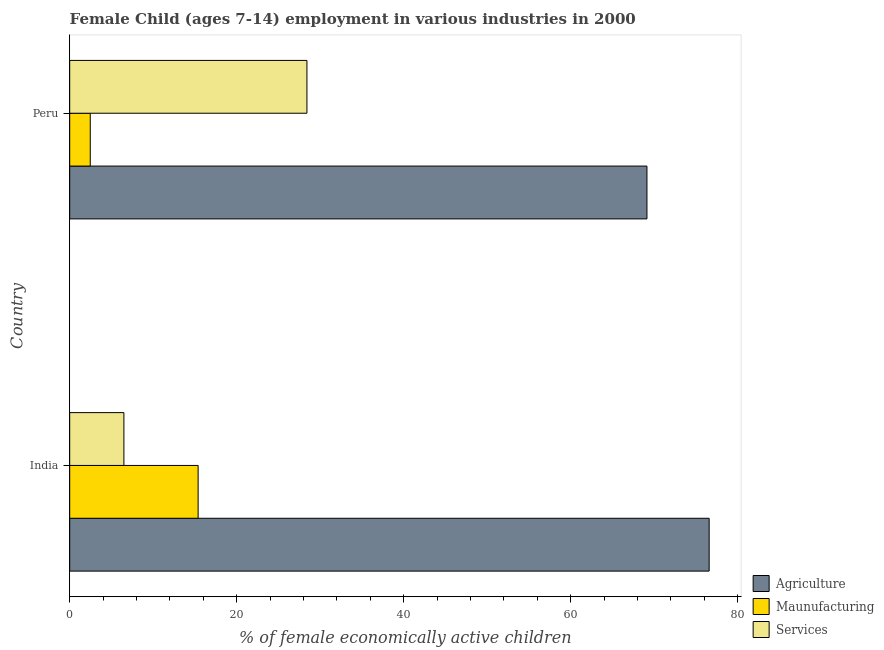How many different coloured bars are there?
Your answer should be very brief. 3. How many bars are there on the 1st tick from the top?
Give a very brief answer. 3. What is the label of the 1st group of bars from the top?
Provide a short and direct response. Peru. In how many cases, is the number of bars for a given country not equal to the number of legend labels?
Provide a succinct answer. 0. What is the percentage of economically active children in agriculture in India?
Give a very brief answer. 76.58. Across all countries, what is the maximum percentage of economically active children in agriculture?
Your answer should be very brief. 76.58. Across all countries, what is the minimum percentage of economically active children in agriculture?
Give a very brief answer. 69.13. In which country was the percentage of economically active children in services maximum?
Provide a succinct answer. Peru. In which country was the percentage of economically active children in manufacturing minimum?
Your answer should be very brief. Peru. What is the total percentage of economically active children in agriculture in the graph?
Your answer should be compact. 145.71. What is the difference between the percentage of economically active children in manufacturing in India and that in Peru?
Ensure brevity in your answer.  12.92. What is the difference between the percentage of economically active children in manufacturing in Peru and the percentage of economically active children in services in India?
Your answer should be compact. -4.03. What is the average percentage of economically active children in services per country?
Keep it short and to the point. 17.45. What is the difference between the percentage of economically active children in agriculture and percentage of economically active children in manufacturing in India?
Ensure brevity in your answer.  61.2. What is the ratio of the percentage of economically active children in agriculture in India to that in Peru?
Your answer should be compact. 1.11. Is the percentage of economically active children in agriculture in India less than that in Peru?
Your answer should be compact. No. Is the difference between the percentage of economically active children in manufacturing in India and Peru greater than the difference between the percentage of economically active children in services in India and Peru?
Ensure brevity in your answer.  Yes. What does the 3rd bar from the top in Peru represents?
Give a very brief answer. Agriculture. What does the 3rd bar from the bottom in India represents?
Offer a very short reply. Services. Is it the case that in every country, the sum of the percentage of economically active children in agriculture and percentage of economically active children in manufacturing is greater than the percentage of economically active children in services?
Your response must be concise. Yes. How many bars are there?
Offer a very short reply. 6. Are all the bars in the graph horizontal?
Your answer should be very brief. Yes. How many countries are there in the graph?
Provide a succinct answer. 2. What is the difference between two consecutive major ticks on the X-axis?
Ensure brevity in your answer.  20. Does the graph contain grids?
Offer a terse response. No. Where does the legend appear in the graph?
Offer a very short reply. Bottom right. What is the title of the graph?
Offer a terse response. Female Child (ages 7-14) employment in various industries in 2000. Does "Ages 65 and above" appear as one of the legend labels in the graph?
Provide a succinct answer. No. What is the label or title of the X-axis?
Your response must be concise. % of female economically active children. What is the % of female economically active children of Agriculture in India?
Your response must be concise. 76.58. What is the % of female economically active children in Maunufacturing in India?
Offer a terse response. 15.38. What is the % of female economically active children in Services in India?
Offer a very short reply. 6.49. What is the % of female economically active children in Agriculture in Peru?
Offer a very short reply. 69.13. What is the % of female economically active children in Maunufacturing in Peru?
Your answer should be compact. 2.46. What is the % of female economically active children of Services in Peru?
Your response must be concise. 28.41. Across all countries, what is the maximum % of female economically active children in Agriculture?
Ensure brevity in your answer.  76.58. Across all countries, what is the maximum % of female economically active children in Maunufacturing?
Give a very brief answer. 15.38. Across all countries, what is the maximum % of female economically active children of Services?
Provide a short and direct response. 28.41. Across all countries, what is the minimum % of female economically active children of Agriculture?
Make the answer very short. 69.13. Across all countries, what is the minimum % of female economically active children of Maunufacturing?
Your answer should be compact. 2.46. Across all countries, what is the minimum % of female economically active children of Services?
Ensure brevity in your answer.  6.49. What is the total % of female economically active children of Agriculture in the graph?
Give a very brief answer. 145.71. What is the total % of female economically active children of Maunufacturing in the graph?
Ensure brevity in your answer.  17.84. What is the total % of female economically active children in Services in the graph?
Provide a short and direct response. 34.9. What is the difference between the % of female economically active children in Agriculture in India and that in Peru?
Ensure brevity in your answer.  7.45. What is the difference between the % of female economically active children in Maunufacturing in India and that in Peru?
Offer a terse response. 12.92. What is the difference between the % of female economically active children in Services in India and that in Peru?
Ensure brevity in your answer.  -21.92. What is the difference between the % of female economically active children of Agriculture in India and the % of female economically active children of Maunufacturing in Peru?
Your response must be concise. 74.12. What is the difference between the % of female economically active children in Agriculture in India and the % of female economically active children in Services in Peru?
Offer a very short reply. 48.17. What is the difference between the % of female economically active children in Maunufacturing in India and the % of female economically active children in Services in Peru?
Keep it short and to the point. -13.03. What is the average % of female economically active children in Agriculture per country?
Your answer should be very brief. 72.86. What is the average % of female economically active children in Maunufacturing per country?
Your answer should be compact. 8.92. What is the average % of female economically active children of Services per country?
Provide a succinct answer. 17.45. What is the difference between the % of female economically active children of Agriculture and % of female economically active children of Maunufacturing in India?
Your answer should be compact. 61.2. What is the difference between the % of female economically active children of Agriculture and % of female economically active children of Services in India?
Provide a succinct answer. 70.09. What is the difference between the % of female economically active children of Maunufacturing and % of female economically active children of Services in India?
Your response must be concise. 8.89. What is the difference between the % of female economically active children of Agriculture and % of female economically active children of Maunufacturing in Peru?
Provide a short and direct response. 66.67. What is the difference between the % of female economically active children in Agriculture and % of female economically active children in Services in Peru?
Provide a short and direct response. 40.72. What is the difference between the % of female economically active children in Maunufacturing and % of female economically active children in Services in Peru?
Make the answer very short. -25.95. What is the ratio of the % of female economically active children in Agriculture in India to that in Peru?
Ensure brevity in your answer.  1.11. What is the ratio of the % of female economically active children in Maunufacturing in India to that in Peru?
Your answer should be compact. 6.25. What is the ratio of the % of female economically active children in Services in India to that in Peru?
Make the answer very short. 0.23. What is the difference between the highest and the second highest % of female economically active children in Agriculture?
Your answer should be very brief. 7.45. What is the difference between the highest and the second highest % of female economically active children of Maunufacturing?
Provide a short and direct response. 12.92. What is the difference between the highest and the second highest % of female economically active children of Services?
Make the answer very short. 21.92. What is the difference between the highest and the lowest % of female economically active children of Agriculture?
Keep it short and to the point. 7.45. What is the difference between the highest and the lowest % of female economically active children of Maunufacturing?
Your answer should be compact. 12.92. What is the difference between the highest and the lowest % of female economically active children of Services?
Your answer should be compact. 21.92. 